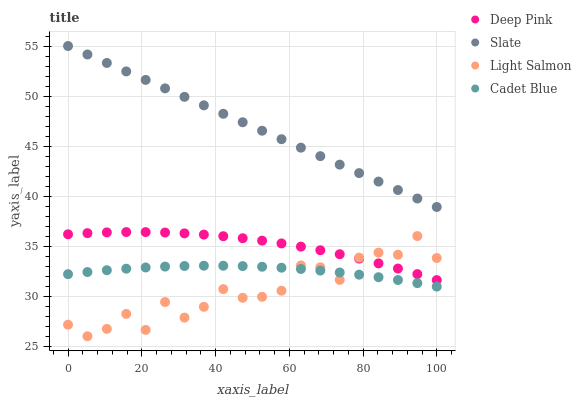Does Light Salmon have the minimum area under the curve?
Answer yes or no. Yes. Does Slate have the maximum area under the curve?
Answer yes or no. Yes. Does Deep Pink have the minimum area under the curve?
Answer yes or no. No. Does Deep Pink have the maximum area under the curve?
Answer yes or no. No. Is Slate the smoothest?
Answer yes or no. Yes. Is Light Salmon the roughest?
Answer yes or no. Yes. Is Deep Pink the smoothest?
Answer yes or no. No. Is Deep Pink the roughest?
Answer yes or no. No. Does Light Salmon have the lowest value?
Answer yes or no. Yes. Does Deep Pink have the lowest value?
Answer yes or no. No. Does Slate have the highest value?
Answer yes or no. Yes. Does Deep Pink have the highest value?
Answer yes or no. No. Is Cadet Blue less than Slate?
Answer yes or no. Yes. Is Slate greater than Deep Pink?
Answer yes or no. Yes. Does Cadet Blue intersect Light Salmon?
Answer yes or no. Yes. Is Cadet Blue less than Light Salmon?
Answer yes or no. No. Is Cadet Blue greater than Light Salmon?
Answer yes or no. No. Does Cadet Blue intersect Slate?
Answer yes or no. No. 